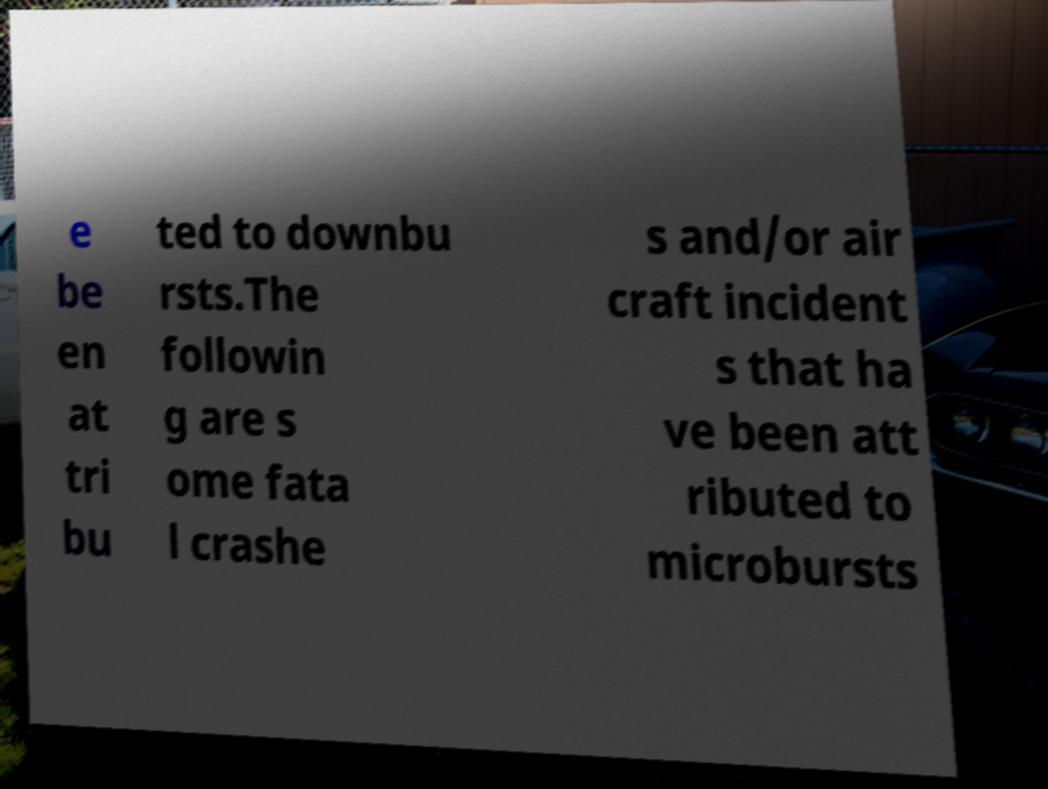Could you assist in decoding the text presented in this image and type it out clearly? e be en at tri bu ted to downbu rsts.The followin g are s ome fata l crashe s and/or air craft incident s that ha ve been att ributed to microbursts 